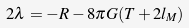Convert formula to latex. <formula><loc_0><loc_0><loc_500><loc_500>2 \lambda = - R - 8 \pi G ( T + 2 l _ { M } )</formula> 